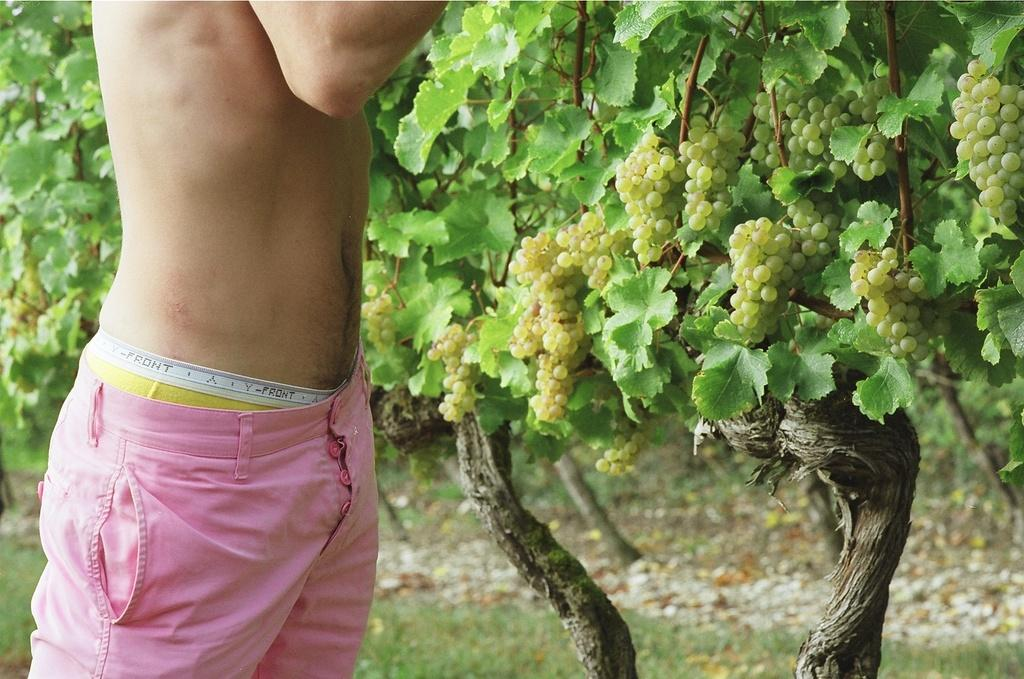Who or what is located at the left side of the image? There is a person standing at the left side of the image. What can be seen in the background of the image? There is a grape tree in the background of the image. What type of fruit is visible at the right side of the image? There are grapes visible at the right side of the image. Where is the shop located in the image? There is no shop present in the image. What type of beast can be seen interacting with the grapes in the image? There is no beast present in the image; only the person, grape tree, and grapes are visible. 